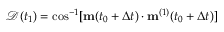<formula> <loc_0><loc_0><loc_500><loc_500>\ m a t h s c r { D } ( t _ { 1 } ) = \cos ^ { - 1 } [ m ( t _ { 0 } + \Delta t ) \cdot m ^ { ( 1 ) } ( t _ { 0 } + \Delta t ) ]</formula> 